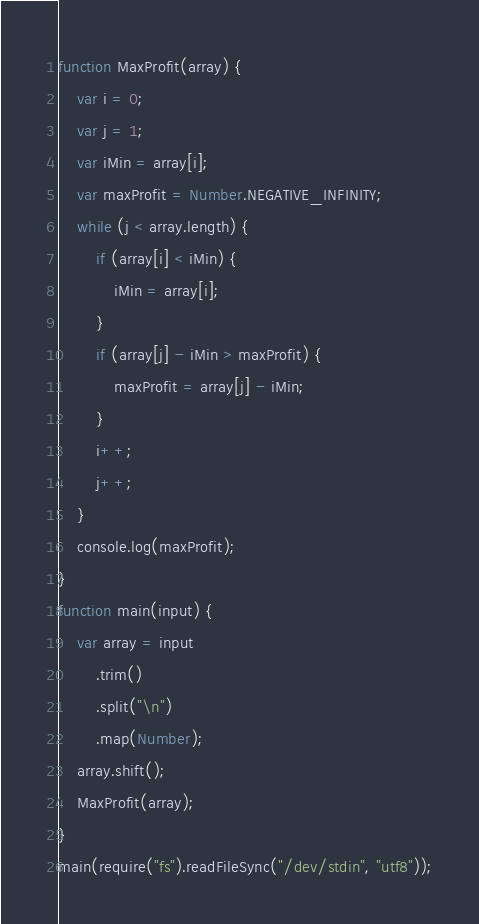<code> <loc_0><loc_0><loc_500><loc_500><_JavaScript_>function MaxProfit(array) {
    var i = 0;
    var j = 1;
    var iMin = array[i];
    var maxProfit = Number.NEGATIVE_INFINITY;
    while (j < array.length) {
        if (array[i] < iMin) {
            iMin = array[i];
        }
        if (array[j] - iMin > maxProfit) {
            maxProfit = array[j] - iMin;
        }
        i++;
        j++;
    }
    console.log(maxProfit);
}
function main(input) {
    var array = input
        .trim()
        .split("\n")
        .map(Number);
    array.shift();
    MaxProfit(array);
}
main(require("fs").readFileSync("/dev/stdin", "utf8"));

</code> 